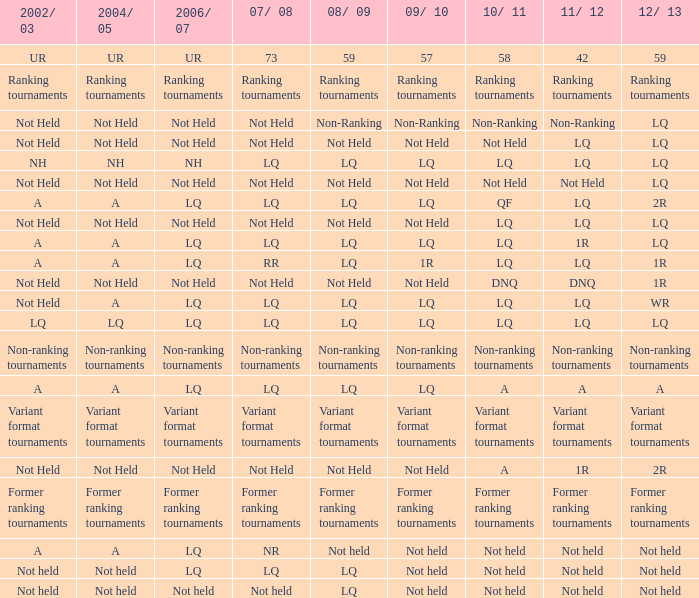Name the 2008/09 with 2004/05 of ranking tournaments Ranking tournaments. 